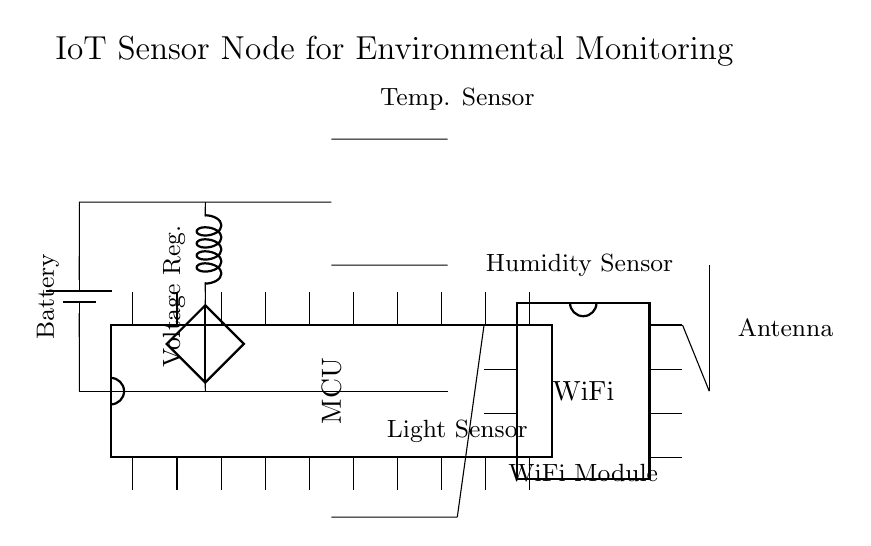What are the main components used in the circuit? The main components include a microcontroller, a battery, a voltage regulator, temperature sensor, humidity sensor, light sensor, a WiFi module, and an antenna.
Answer: microcontroller, battery, voltage regulator, temperature sensor, humidity sensor, light sensor, WiFi module, antenna What is the function of the voltage regulator in this circuit? The voltage regulator ensures that the voltage supplied to the microcontroller and sensors remains stable and within the required limits, preventing damage from voltage fluctuations.
Answer: voltage stabilization What sensors are used for environmental monitoring? The sensors used include a temperature sensor, a humidity sensor, and a light sensor.
Answer: temperature sensor, humidity sensor, light sensor In what position is the WiFi module placed relative to the microcontroller? The WiFi module is placed to the right of the microcontroller in the circuit diagram.
Answer: right How does the power supply connect to the voltage regulator? The power supply is connected to the voltage regulator with a short connection line from the battery to the input side of the voltage regulator.
Answer: short connection line How does the circuit handle wireless communication? The circuit uses a WiFi module connected to the microcontroller, which is then linked to an antenna for wireless communication.
Answer: WiFi module and antenna Where is the light sensor located in the circuit? The light sensor is positioned at the bottom of the circuit diagram.
Answer: bottom 